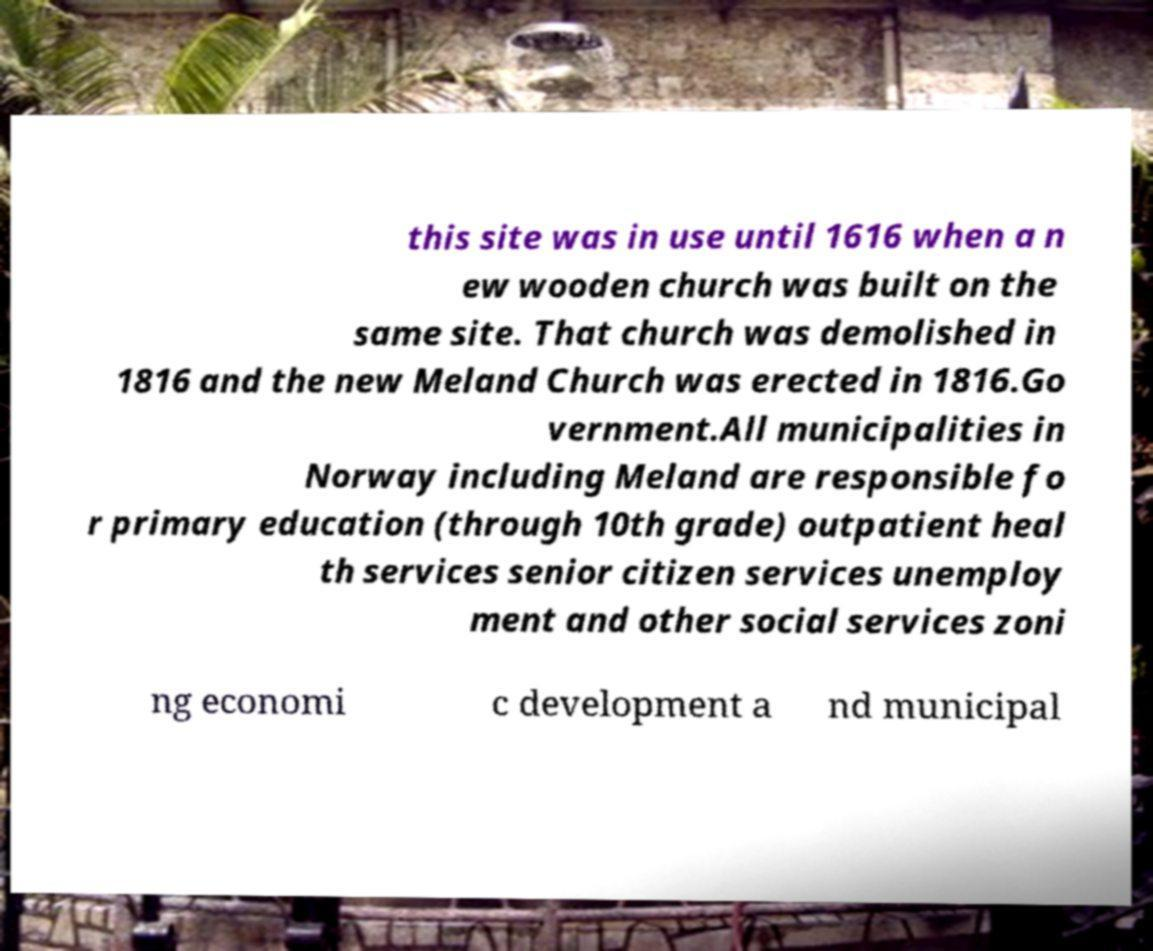Could you extract and type out the text from this image? this site was in use until 1616 when a n ew wooden church was built on the same site. That church was demolished in 1816 and the new Meland Church was erected in 1816.Go vernment.All municipalities in Norway including Meland are responsible fo r primary education (through 10th grade) outpatient heal th services senior citizen services unemploy ment and other social services zoni ng economi c development a nd municipal 